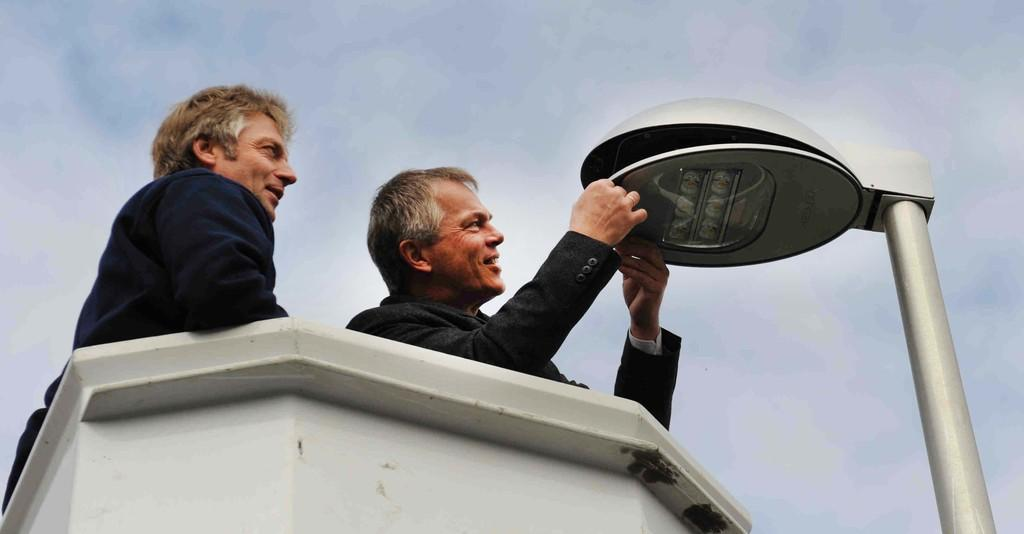How many people are in the image? There are two men in the image. What is the facial expression of the men in the image? The men are smiling. What object can be seen in the image that is typically used for support or guidance? There is a pole in the image. What is the source of illumination in the image? There is a light in the image. What can be seen in the background of the image? The sky with clouds is visible in the background of the image. What type of regret can be seen on the mother's face in the image? There is no mother present in the image, and therefore no facial expression of regret can be observed. 